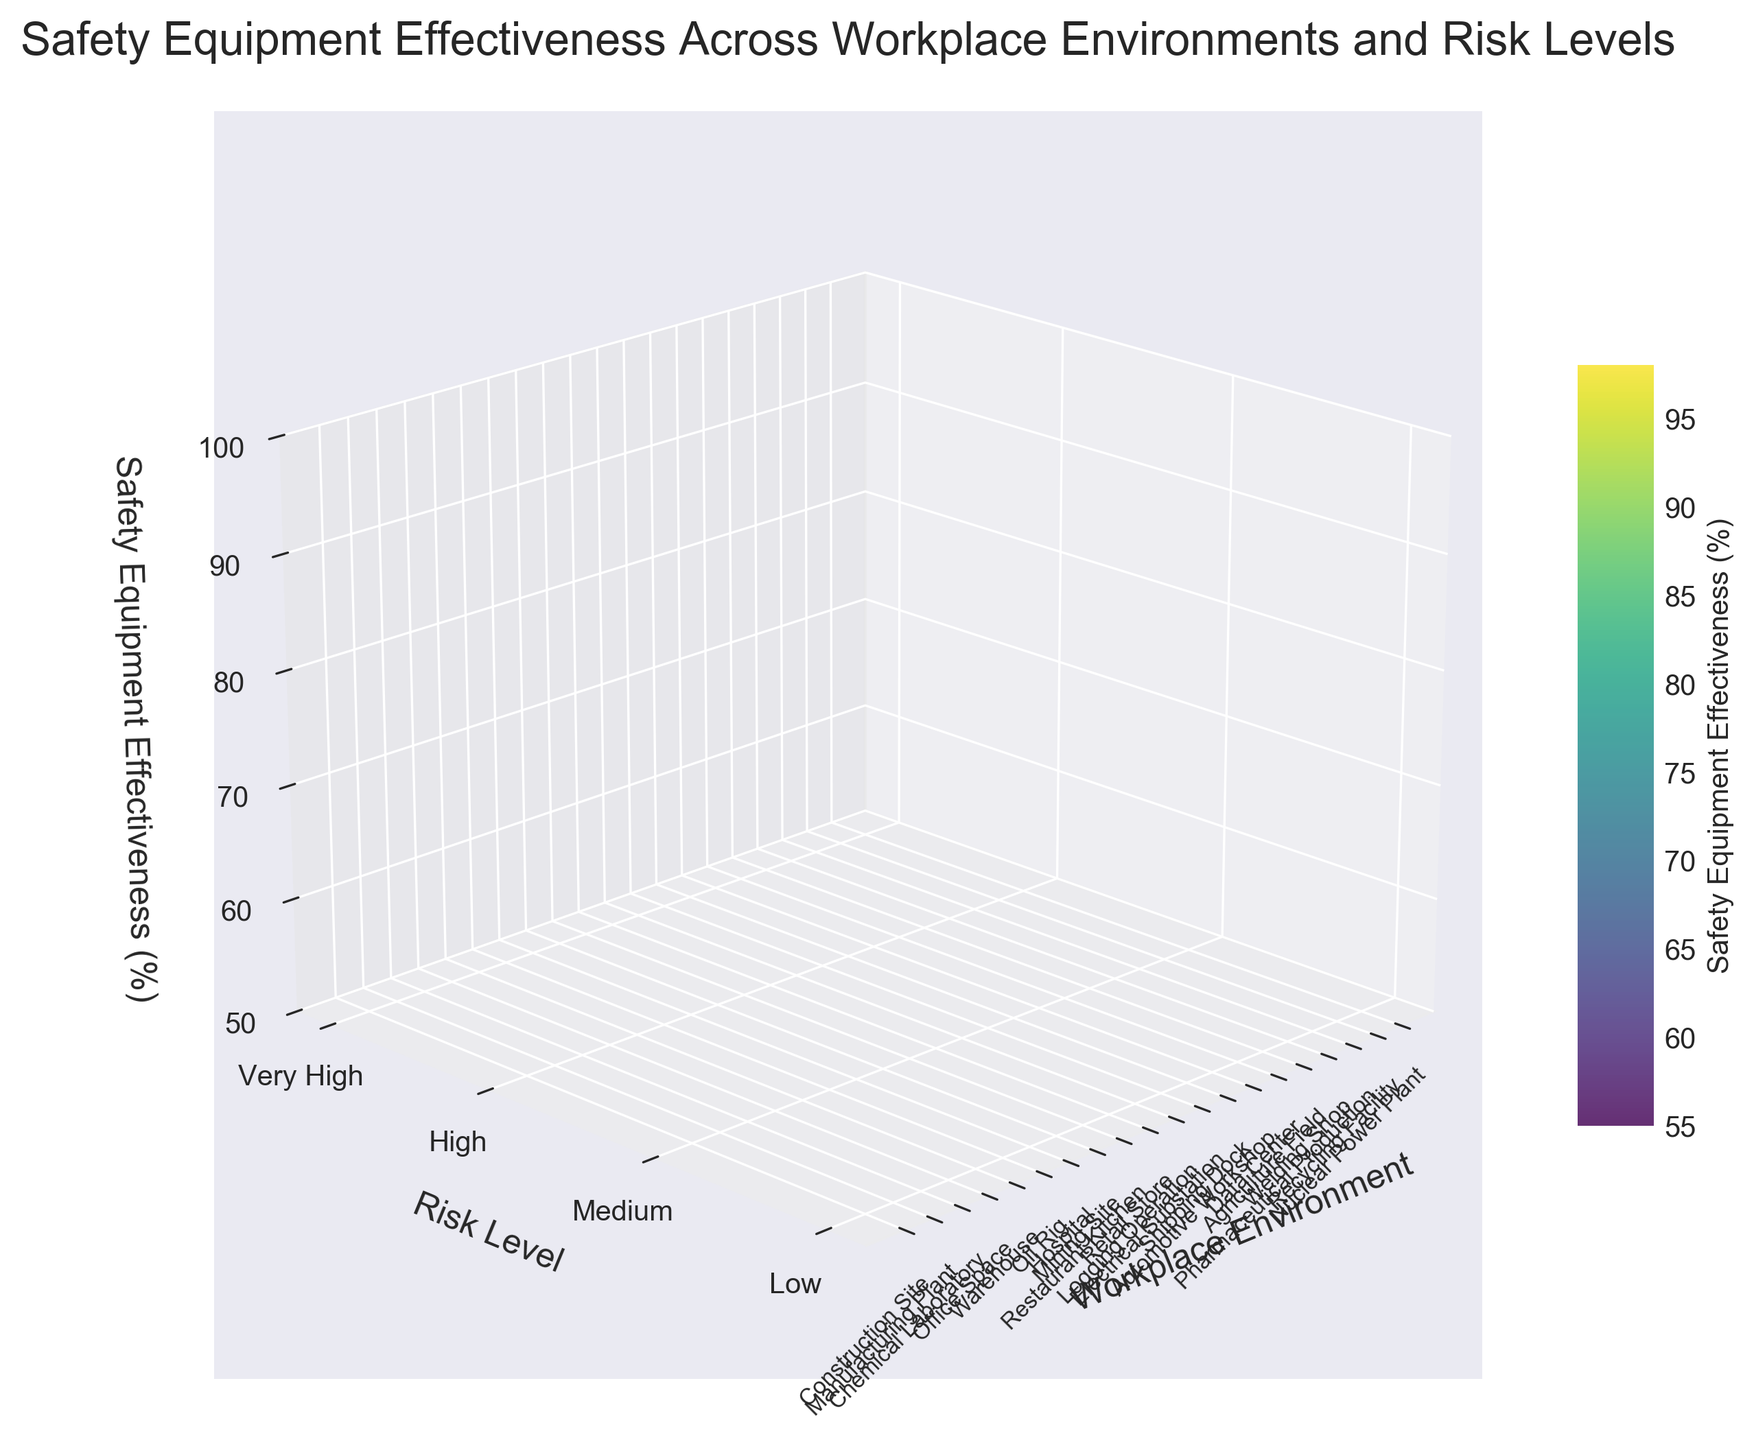What is the title of the 3D surface plot? The title of the plot is displayed at the top center of the figure. It introduces the main topic of the visualization.
Answer: Safety Equipment Effectiveness Across Workplace Environments and Risk Levels What is the color scale used to represent safety equipment effectiveness? The color scale for the safety equipment effectiveness is provided by the color bar on the side of the figure. It ranges from one color to another to indicate the effectiveness percentages.
Answer: Viridis Which workplace environment shows the highest safety equipment effectiveness at a 'Very High' risk level? Observe the 'Very High' risk level row and find the peak value. The corresponding workplace environment on the x-axis represents the environment with the highest effectiveness.
Answer: Nuclear Power Plant How does the effectiveness of safety equipment in 'Oil Rig' compare to that in 'Mining Site' at the 'Very High' risk level? Locate the 'Very High' risk level row and compare the effectiveness values above 'Oil Rig' and 'Mining Site'. Check which one is higher.
Answer: Oil Rig has a higher effectiveness Which workplace environment has the least safety equipment effectiveness at the 'Medium' risk level? Identify the 'Medium' risk level row and find the lowest effectiveness value. The corresponding environment on the x-axis shows the one with the least effectiveness.
Answer: Agriculture Field What is the average safety equipment effectiveness for environments categorized under 'High' risk level? Sum the effectiveness values for 'High' risk level environments and divide by the total count of these environments to find the average.  [85+90+88+89+87+91] / 6 = 88.33
Answer: 88.33 Are there any workplace environments where safety equipment effectiveness data is missing? Look for any gaps or missing portions in the surface plot. These gaps indicate missing data points.
Answer: No missing data points Which workplace environment shows the lowest effectiveness at the 'Low' risk level? Identify the 'Low' risk level row and find the minimum effectiveness value. The corresponding environment on the x-axis represents the one with the lowest effectiveness.
Answer: Retail Store In which risk levels does the 'Construction Site' have recorded safety equipment effectiveness? Trace the 'Construction Site' along the x-axis and observe under which risk levels data points are present.
Answer: High Is there a correlation between risk level and safety equipment effectiveness across workplace environments? Observe the trend in effectiveness values across different risk levels. If higher risk levels generally show higher effectiveness, that indicates a positive correlation, and vice versa.
Answer: Positive correlation Are the safety equipment effectiveness values above 60% in all workplace environments? Check the range of effectiveness values across the surface. Verify that all values are above 60%.
Answer: No, Office Space and Retail Store are below 60% 